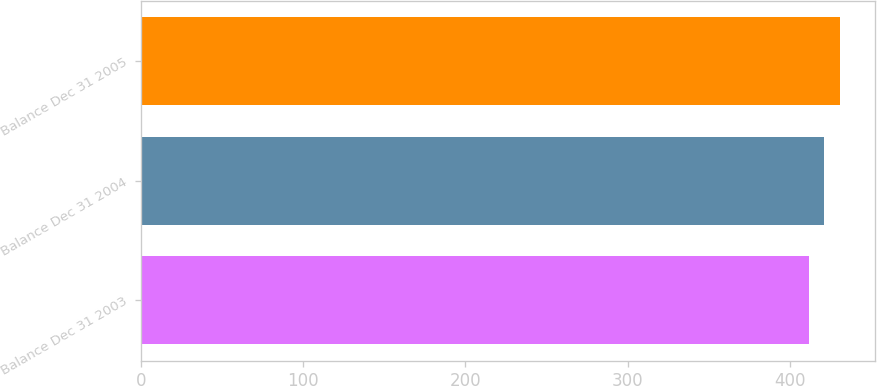Convert chart to OTSL. <chart><loc_0><loc_0><loc_500><loc_500><bar_chart><fcel>Balance Dec 31 2003<fcel>Balance Dec 31 2004<fcel>Balance Dec 31 2005<nl><fcel>412<fcel>421<fcel>431<nl></chart> 